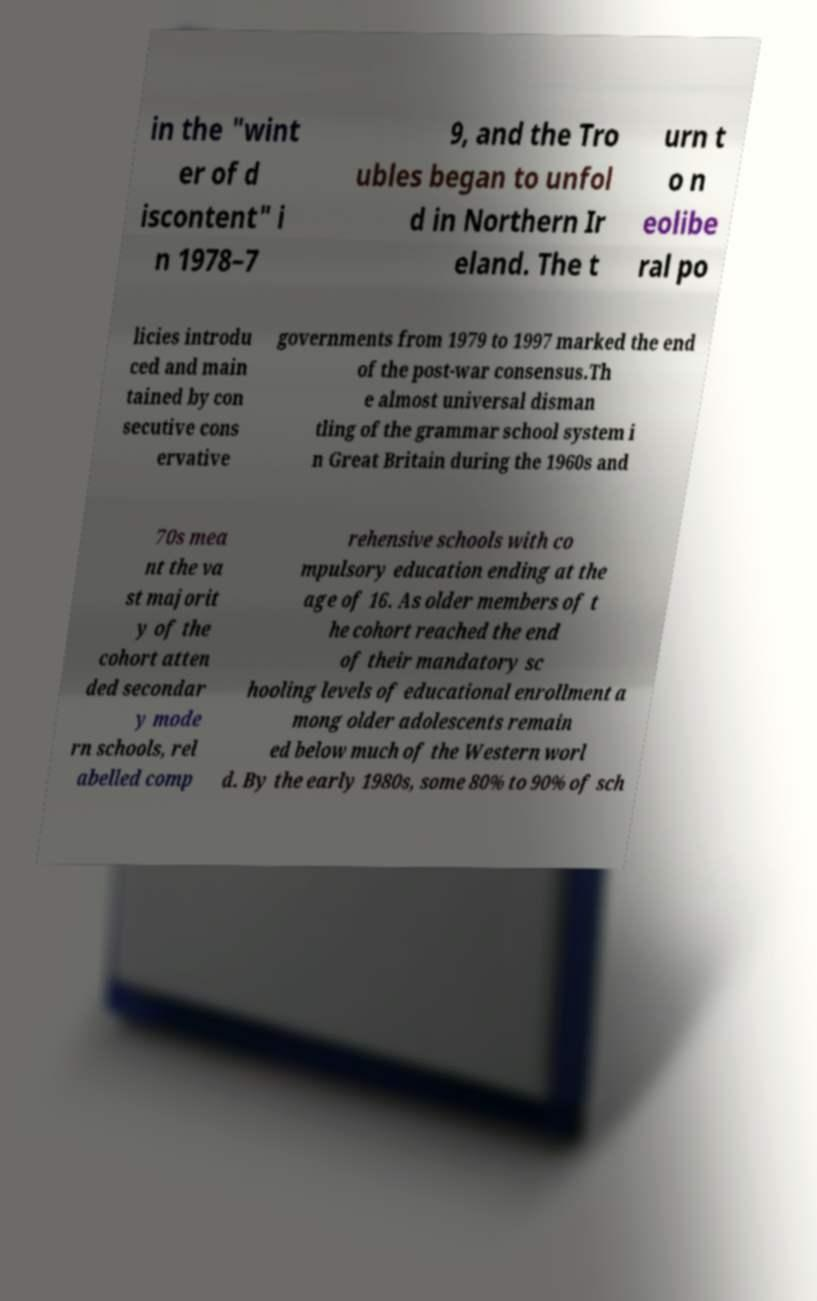I need the written content from this picture converted into text. Can you do that? in the "wint er of d iscontent" i n 1978–7 9, and the Tro ubles began to unfol d in Northern Ir eland. The t urn t o n eolibe ral po licies introdu ced and main tained by con secutive cons ervative governments from 1979 to 1997 marked the end of the post-war consensus.Th e almost universal disman tling of the grammar school system i n Great Britain during the 1960s and 70s mea nt the va st majorit y of the cohort atten ded secondar y mode rn schools, rel abelled comp rehensive schools with co mpulsory education ending at the age of 16. As older members of t he cohort reached the end of their mandatory sc hooling levels of educational enrollment a mong older adolescents remain ed below much of the Western worl d. By the early 1980s, some 80% to 90% of sch 